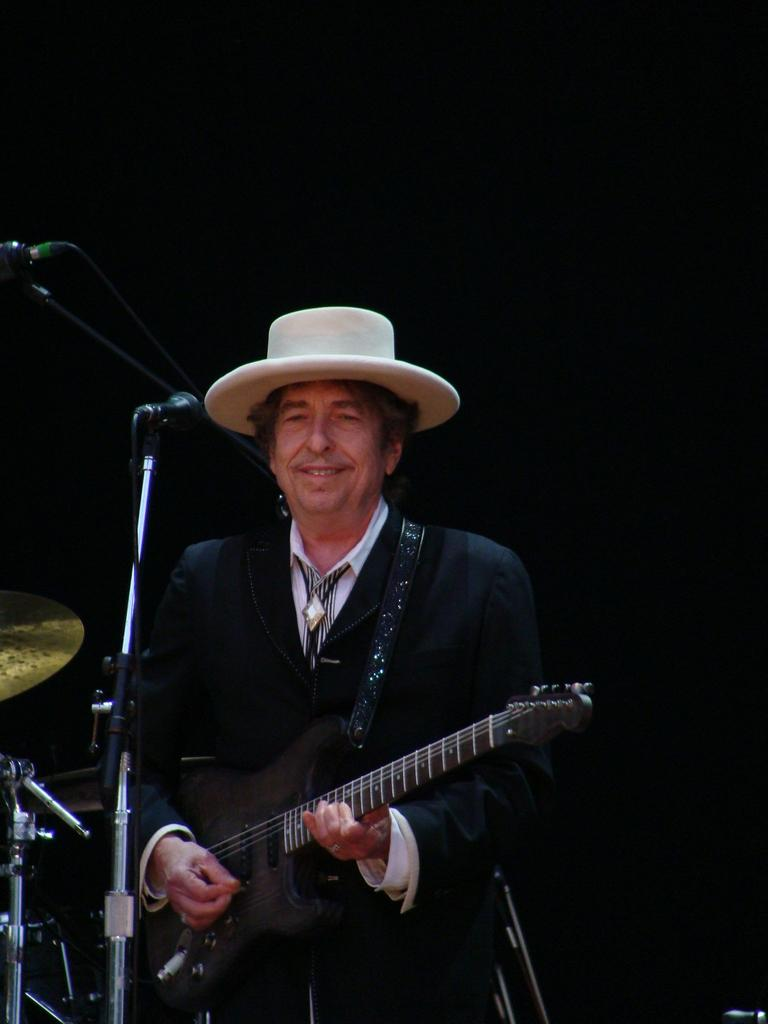What is the man in the image doing? The man is playing a guitar in the image. What object is present in the image that is typically used for amplifying sound? There is a microphone in the image. How does the man appear to feel while playing the guitar? The man is smiling, which suggests he is enjoying himself. How many screws can be seen holding the guitar together in the image? There are no screws visible in the image; the guitar appears to be a solid object. Can you tell me how many times the man sneezes while playing the guitar in the image? There is no indication in the image that the man sneezes while playing the guitar. 